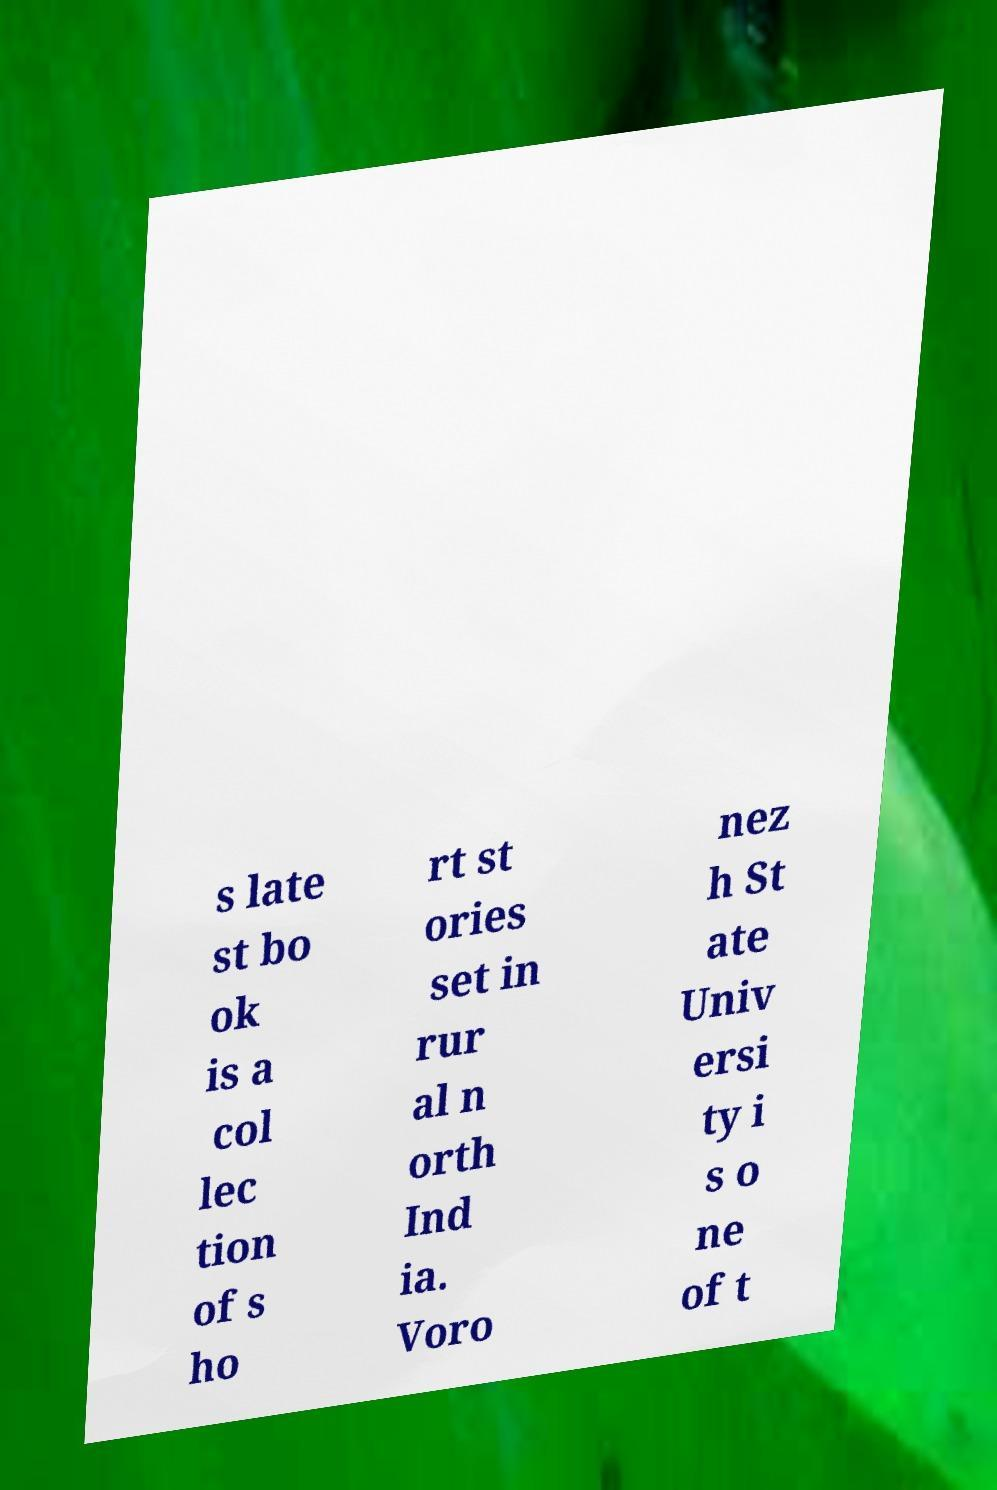Can you read and provide the text displayed in the image?This photo seems to have some interesting text. Can you extract and type it out for me? s late st bo ok is a col lec tion of s ho rt st ories set in rur al n orth Ind ia. Voro nez h St ate Univ ersi ty i s o ne of t 